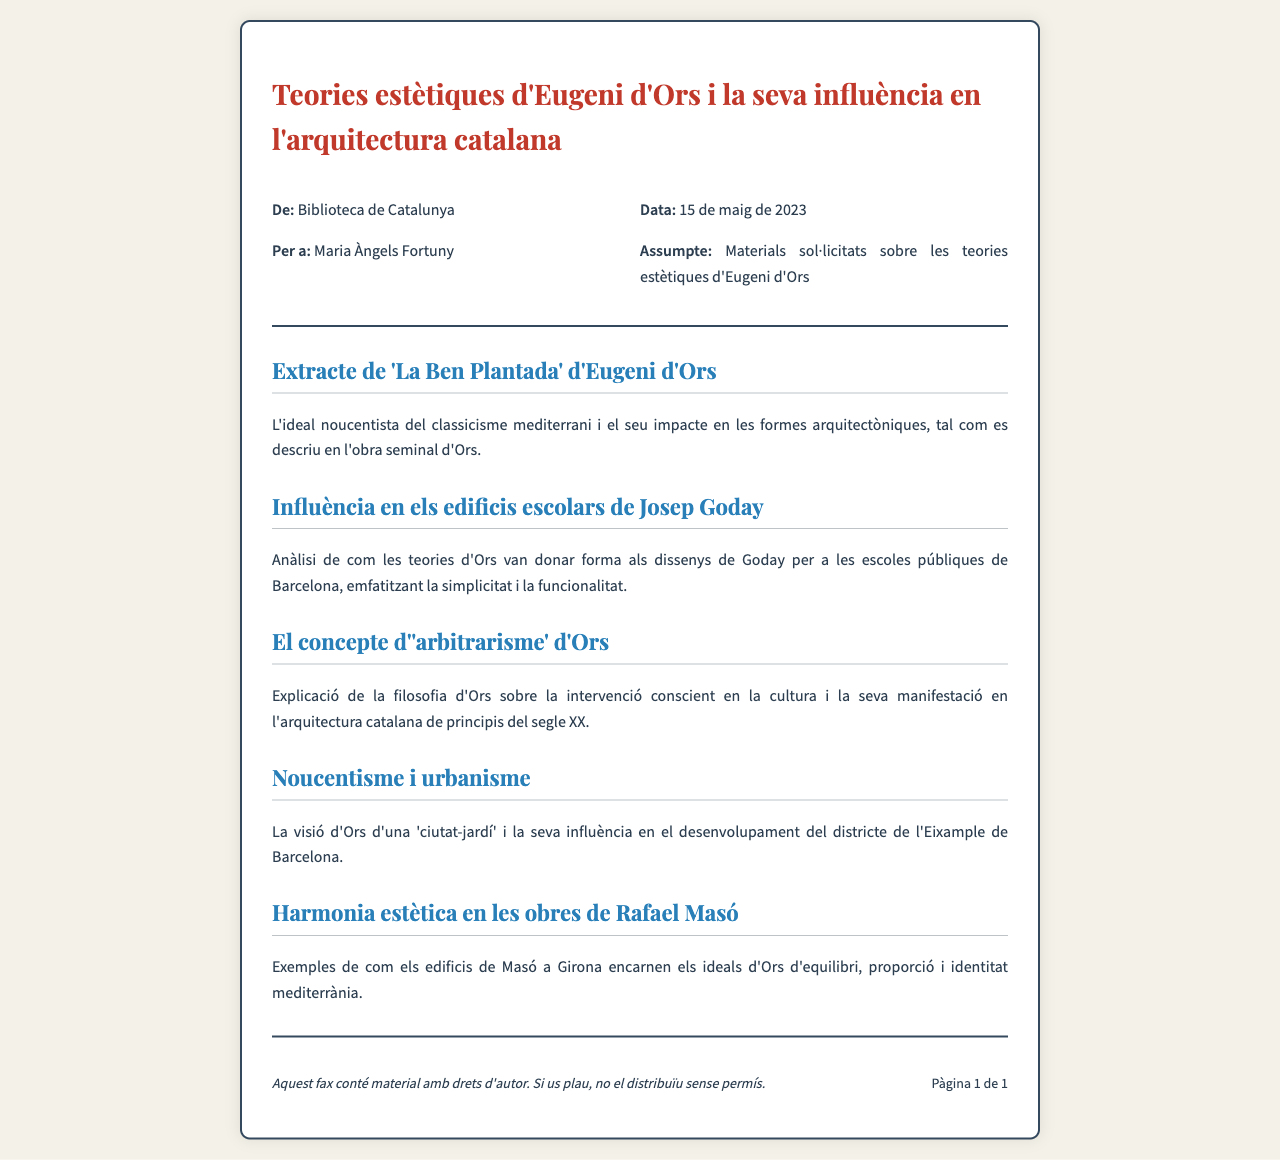Quin és el títol del fax? El títol del fax és la primera línia visible, que indica el tema principal del document.
Answer: Teories estètiques d'Eugeni d'Ors i la seva influència en l'arquitectura catalana Quina data es va enviar el fax? La data d'enviament del fax es troba a la secció d'informació de l'encapçalament.
Answer: 15 de maig de 2023 Quina institució envia el fax? La institució que envia el fax es menciona a la part superior del document, en la secció 'De:'.
Answer: Biblioteca de Catalunya Quines teories d'Eugeni d'Ors es mencionen? Les teories es descriuen en títols com a seccions de contingut dins del document.
Answer: L'ideal noucentista del classicisme mediterrani Quin arquitecte es menciona en relació amb les escoles públiques? Es fa referència a un arquitecte que va integrar les teories d'Ors en els seus dissenys.
Answer: Josep Goday Quin concepte d'Ors està relacionat amb la cultura i l'arquitectura? El concepte es detalla en una secció i és important per entendre la filosofia d'Ors.
Answer: 'arbitrarisme' Quina influència té Ors en el districte de l'Eixample? El document indica que la visió d'Ors influeix en un tipus concret de desenvolupament urbanístic.
Answer: 'ciutat-jardí' Quin és un dels exemples d'arquitectura que reflecteix els ideals d'Ors? L'exemple d'arquitectura es presenta a la secció final del document.
Answer: edificis de Rafael Masó Quin missatge conté la nota del peu del fax? La nota del peu proporciona informació sobre drets d'autor i la distribució del material.
Answer: aquest fax conté material amb drets d'autor 